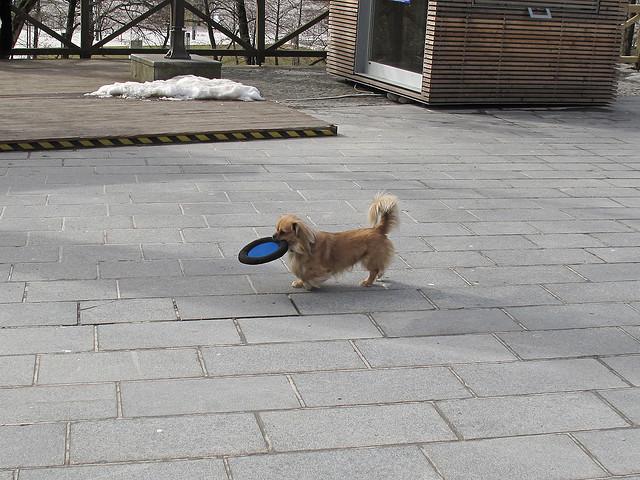What is the dog holding in its mouth?
Answer briefly. Frisbee. What season is it?
Quick response, please. Winter. What breed is the dog in the picture?
Answer briefly. Chihuahua. 